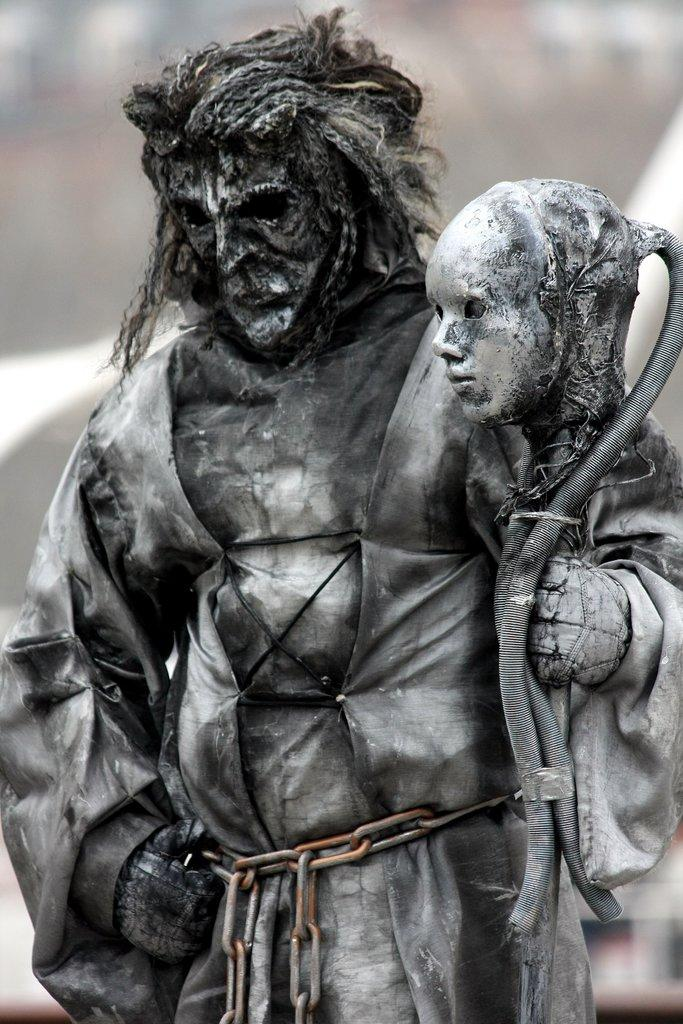What is happening in the image involving a person? There is a person standing in the image, and they are holding another person's head. Can you describe the background of the image? The background of the image is blurred. What type of stove can be seen in the background of the image? There is no stove present in the image; the background is blurred. What time of day is it in the image, considering it's an afternoon scene? The time of day cannot be determined from the image, as there are no clues to suggest it is an afternoon scene. 